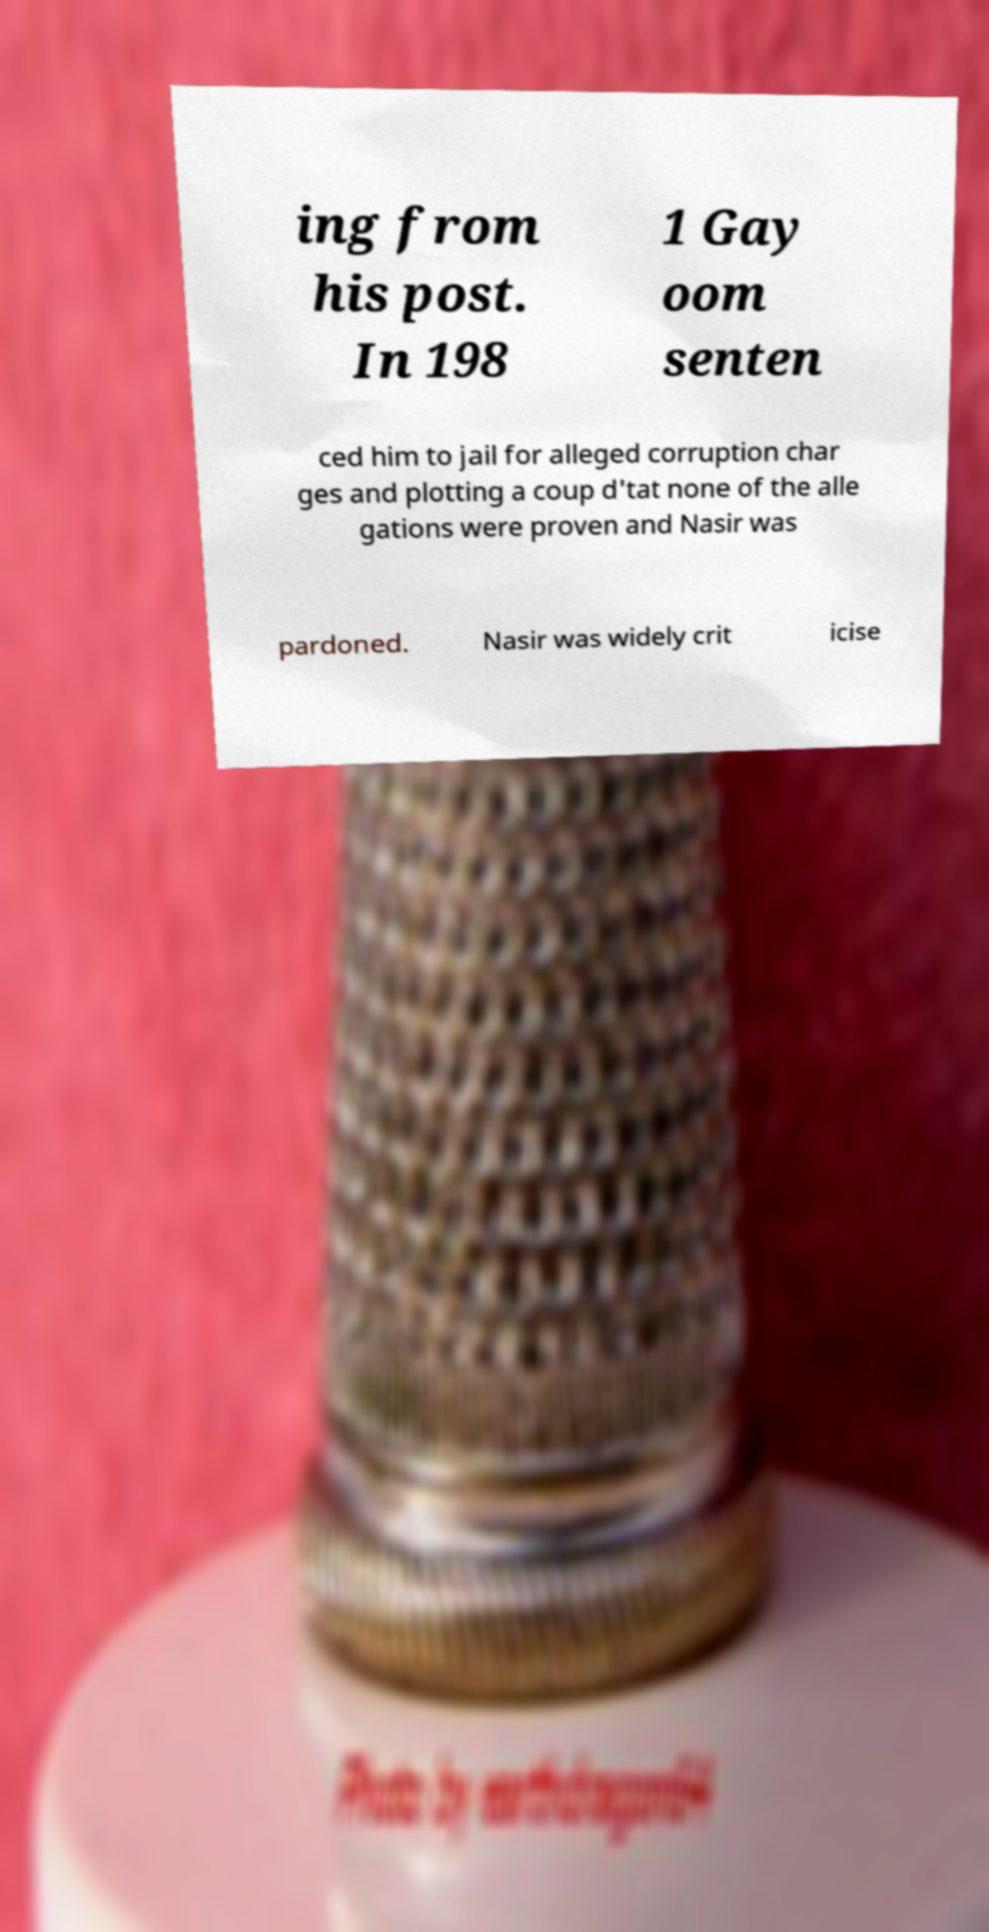There's text embedded in this image that I need extracted. Can you transcribe it verbatim? ing from his post. In 198 1 Gay oom senten ced him to jail for alleged corruption char ges and plotting a coup d'tat none of the alle gations were proven and Nasir was pardoned. Nasir was widely crit icise 